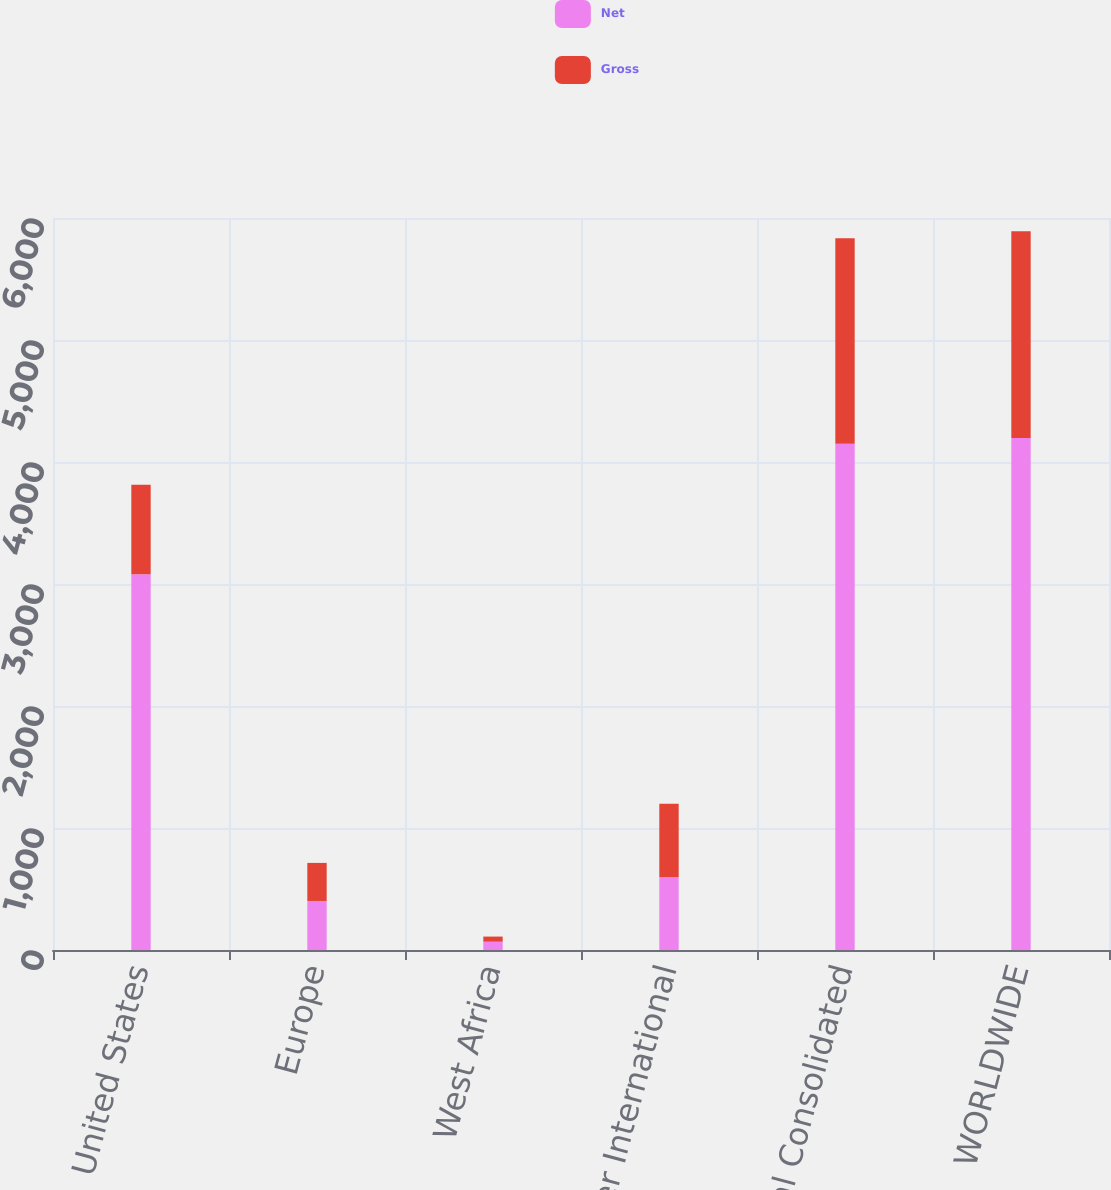Convert chart to OTSL. <chart><loc_0><loc_0><loc_500><loc_500><stacked_bar_chart><ecel><fcel>United States<fcel>Europe<fcel>West Africa<fcel>Other International<fcel>Total Consolidated<fcel>WORLDWIDE<nl><fcel>Net<fcel>3080<fcel>402<fcel>68<fcel>599<fcel>4149<fcel>4196<nl><fcel>Gross<fcel>733<fcel>312<fcel>42<fcel>599<fcel>1686<fcel>1696<nl></chart> 